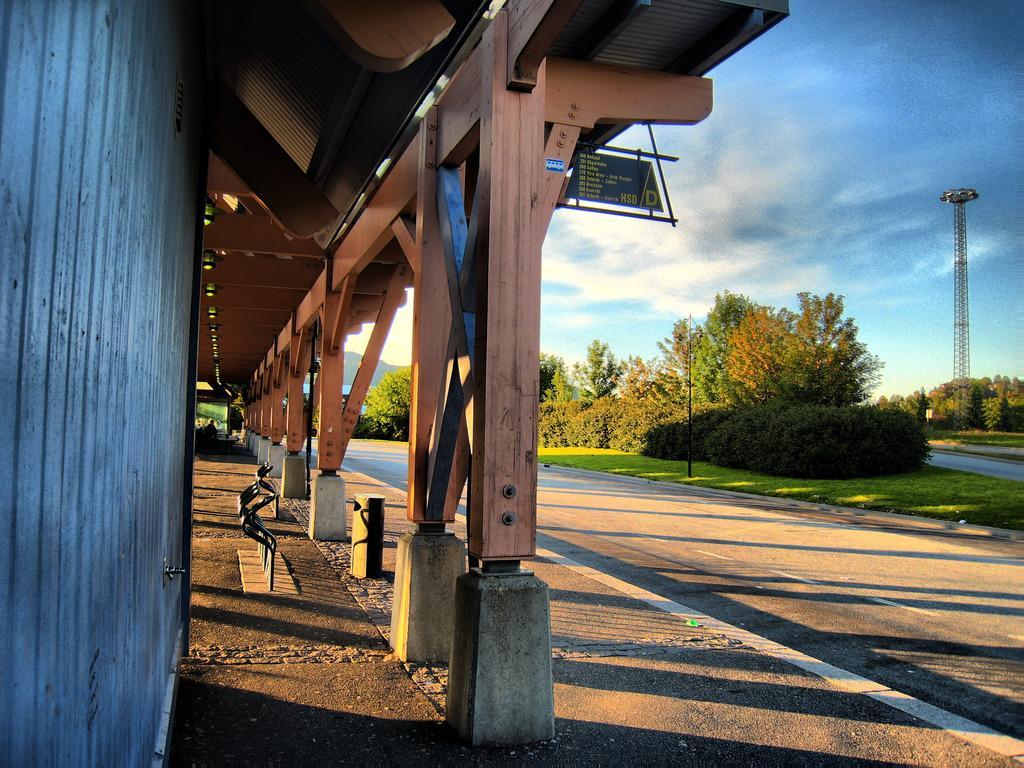Describe this image in one or two sentences. The picture is clicked outside a city. On the left there is a building. In the center of the picture there are trees, grass and road. On the right towards background there are trees and floodlight. Sky is bit cloudy and it is sunny. 